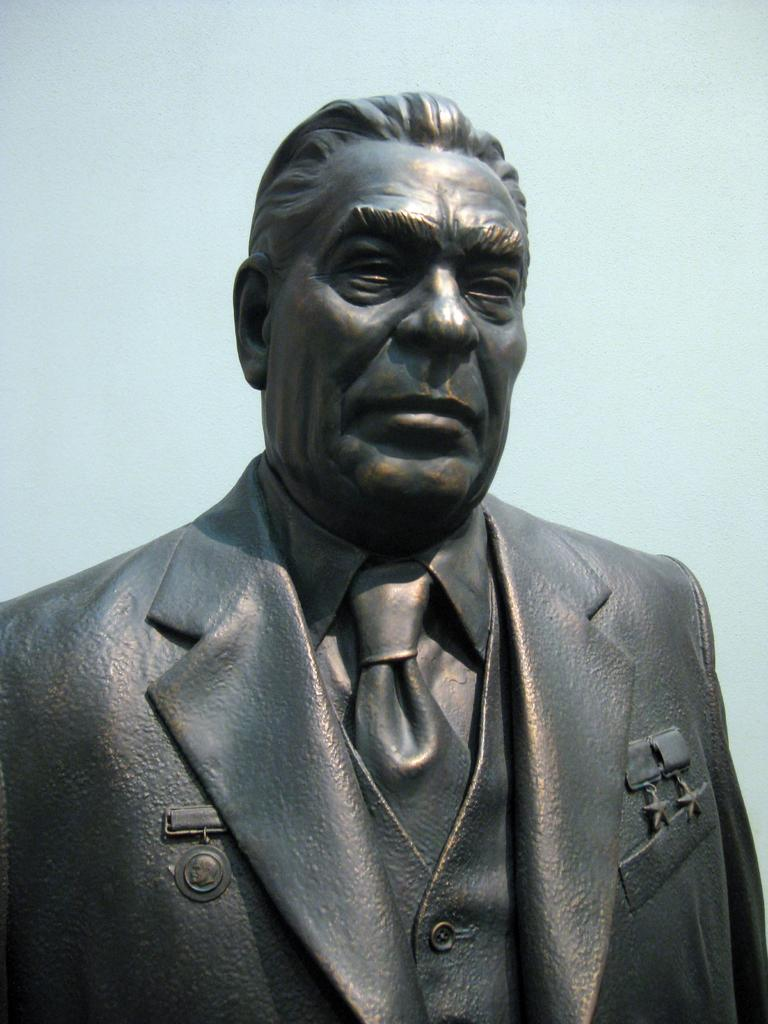What is the main subject of the image? There is a statue of a man in the image. What can be observed about the background of the image? The background color of the image is light blue. Where is the sofa located in the image? There is no sofa present in the image; it only features a statue of a man against a light blue background. 